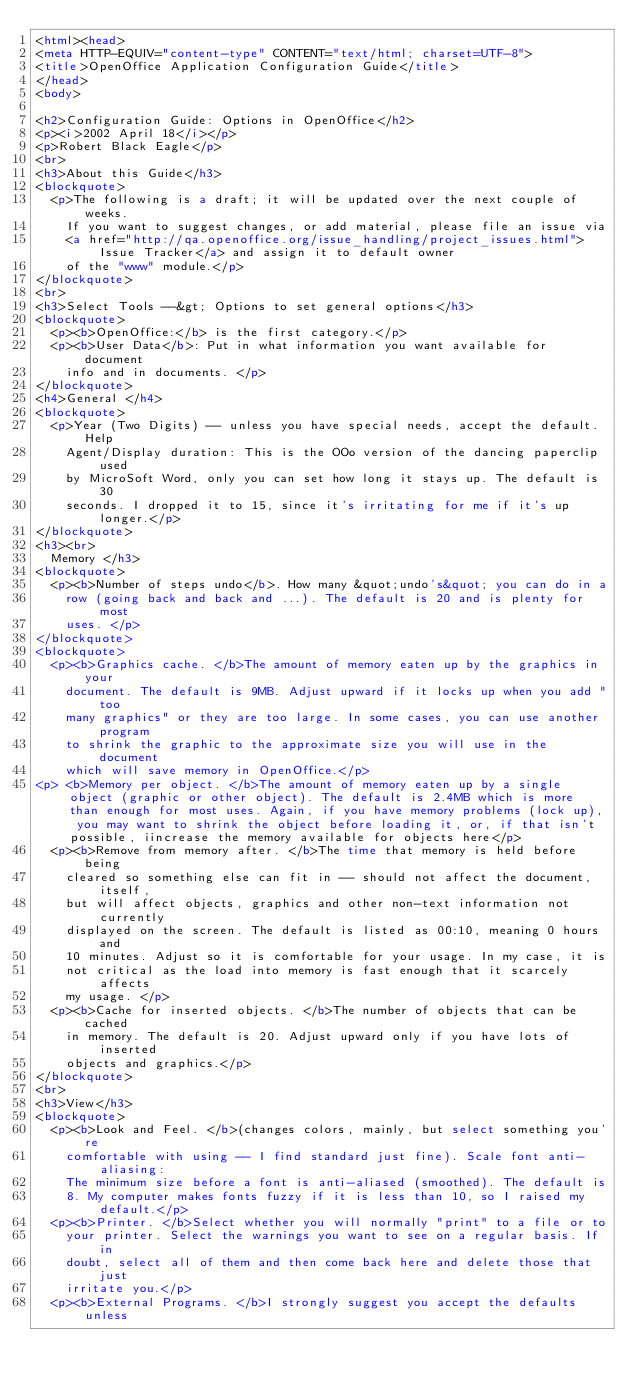Convert code to text. <code><loc_0><loc_0><loc_500><loc_500><_HTML_><html><head>
<meta HTTP-EQUIV="content-type" CONTENT="text/html; charset=UTF-8">
<title>OpenOffice Application Configuration Guide</title>
</head>
<body>

<h2>Configuration Guide: Options in OpenOffice</h2>
<p><i>2002 April 18</i></p>
<p>Robert Black Eagle</p>
<br>
<h3>About this Guide</h3>
<blockquote> 
  <p>The following is a draft; it will be updated over the next couple of weeks. 
    If you want to suggest changes, or add material, please file an issue via 
    <a href="http://qa.openoffice.org/issue_handling/project_issues.html">Issue Tracker</a> and assign it to default owner 
    of the "www" module.</p>
</blockquote>
<br>
<h3>Select Tools --&gt; Options to set general options</h3>
<blockquote> 
  <p><b>OpenOffice:</b> is the first category.</p>
  <p><b>User Data</b>: Put in what information you want available for document 
    info and in documents. </p>
</blockquote>
<h4>General </h4>
<blockquote>
  <p>Year (Two Digits) -- unless you have special needs, accept the default. Help 
    Agent/Display duration: This is the OOo version of the dancing paperclip used 
    by MicroSoft Word, only you can set how long it stays up. The default is 30 
    seconds. I dropped it to 15, since it's irritating for me if it's up longer.</p>
</blockquote>
<h3><br>
  Memory </h3>
<blockquote> 
  <p><b>Number of steps undo</b>. How many &quot;undo's&quot; you can do in a 
    row (going back and back and ...). The default is 20 and is plenty for most 
    uses. </p>
</blockquote>
<blockquote> 
  <p><b>Graphics cache. </b>The amount of memory eaten up by the graphics in your 
    document. The default is 9MB. Adjust upward if it locks up when you add "too 
    many graphics" or they are too large. In some cases, you can use another program 
    to shrink the graphic to the approximate size you will use in the document 
    which will save memory in OpenOffice.</p>
<p> <b>Memory per object. </b>The amount of memory eaten up by a single object (graphic or other object). The default is 2.4MB which is more than enough for most uses. Again, if you have memory problems (lock up), you may want to shrink the object before loading it, or, if that isn't possible, iincrease the memory available for objects here</p>
  <p><b>Remove from memory after. </b>The time that memory is held before being 
    cleared so something else can fit in -- should not affect the document, itself, 
    but will affect objects, graphics and other non-text information not currently 
    displayed on the screen. The default is listed as 00:10, meaning 0 hours and 
    10 minutes. Adjust so it is comfortable for your usage. In my case, it is 
    not critical as the load into memory is fast enough that it scarcely affects 
    my usage. </p>
  <p><b>Cache for inserted objects. </b>The number of objects that can be cached 
    in memory. The default is 20. Adjust upward only if you have lots of inserted 
    objects and graphics.</p>
</blockquote>
<br>
<h3>View</h3>
<blockquote> 
  <p><b>Look and Feel. </b>(changes colors, mainly, but select something you're 
    comfortable with using -- I find standard just fine). Scale font anti-aliasing: 
    The minimum size before a font is anti-aliased (smoothed). The default is 
    8. My computer makes fonts fuzzy if it is less than 10, so I raised my default.</p>
  <p><b>Printer. </b>Select whether you will normally "print" to a file or to 
    your printer. Select the warnings you want to see on a regular basis. If in 
    doubt, select all of them and then come back here and delete those that just 
    irritate you.</p>
  <p><b>External Programs. </b>I strongly suggest you accept the defaults unless </code> 